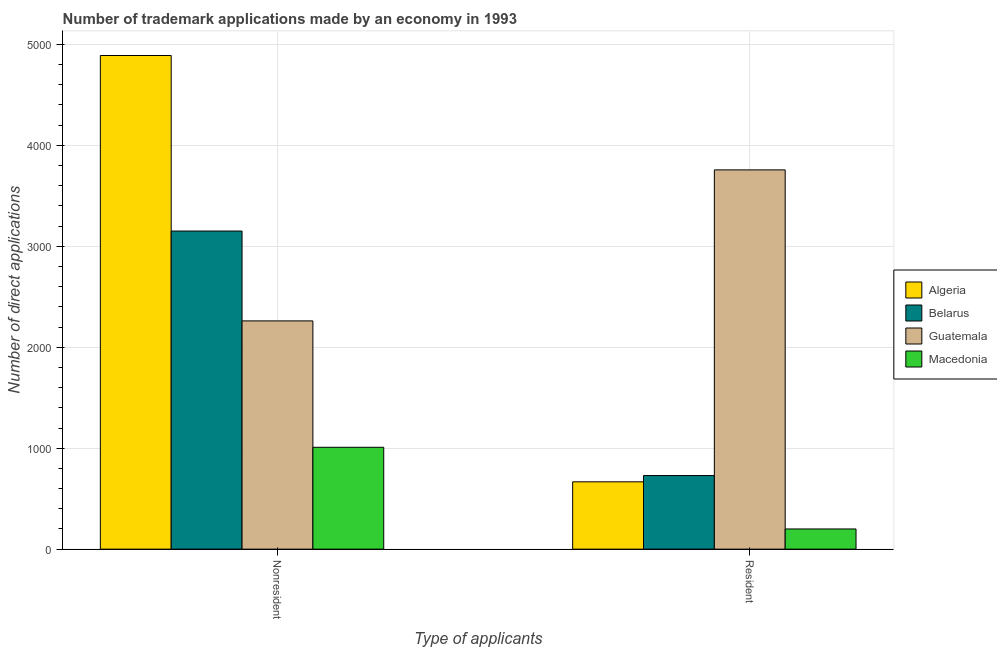How many different coloured bars are there?
Provide a short and direct response. 4. Are the number of bars on each tick of the X-axis equal?
Make the answer very short. Yes. How many bars are there on the 2nd tick from the right?
Give a very brief answer. 4. What is the label of the 1st group of bars from the left?
Make the answer very short. Nonresident. What is the number of trademark applications made by non residents in Algeria?
Offer a very short reply. 4890. Across all countries, what is the maximum number of trademark applications made by residents?
Offer a terse response. 3757. Across all countries, what is the minimum number of trademark applications made by residents?
Provide a succinct answer. 200. In which country was the number of trademark applications made by non residents maximum?
Give a very brief answer. Algeria. In which country was the number of trademark applications made by non residents minimum?
Give a very brief answer. Macedonia. What is the total number of trademark applications made by residents in the graph?
Provide a succinct answer. 5353. What is the difference between the number of trademark applications made by non residents in Guatemala and that in Belarus?
Offer a terse response. -890. What is the difference between the number of trademark applications made by non residents in Algeria and the number of trademark applications made by residents in Macedonia?
Offer a terse response. 4690. What is the average number of trademark applications made by residents per country?
Offer a very short reply. 1338.25. What is the difference between the number of trademark applications made by non residents and number of trademark applications made by residents in Macedonia?
Give a very brief answer. 809. In how many countries, is the number of trademark applications made by non residents greater than 1200 ?
Give a very brief answer. 3. What is the ratio of the number of trademark applications made by residents in Macedonia to that in Algeria?
Give a very brief answer. 0.3. Is the number of trademark applications made by residents in Belarus less than that in Algeria?
Your answer should be very brief. No. In how many countries, is the number of trademark applications made by residents greater than the average number of trademark applications made by residents taken over all countries?
Keep it short and to the point. 1. What does the 4th bar from the left in Nonresident represents?
Your answer should be compact. Macedonia. What does the 4th bar from the right in Resident represents?
Provide a short and direct response. Algeria. What is the difference between two consecutive major ticks on the Y-axis?
Your answer should be very brief. 1000. Does the graph contain any zero values?
Offer a very short reply. No. How are the legend labels stacked?
Your answer should be very brief. Vertical. What is the title of the graph?
Give a very brief answer. Number of trademark applications made by an economy in 1993. Does "Greenland" appear as one of the legend labels in the graph?
Give a very brief answer. No. What is the label or title of the X-axis?
Your answer should be very brief. Type of applicants. What is the label or title of the Y-axis?
Ensure brevity in your answer.  Number of direct applications. What is the Number of direct applications of Algeria in Nonresident?
Offer a terse response. 4890. What is the Number of direct applications in Belarus in Nonresident?
Provide a short and direct response. 3151. What is the Number of direct applications in Guatemala in Nonresident?
Keep it short and to the point. 2261. What is the Number of direct applications in Macedonia in Nonresident?
Make the answer very short. 1009. What is the Number of direct applications of Algeria in Resident?
Give a very brief answer. 667. What is the Number of direct applications in Belarus in Resident?
Offer a terse response. 729. What is the Number of direct applications in Guatemala in Resident?
Offer a very short reply. 3757. What is the Number of direct applications in Macedonia in Resident?
Your answer should be very brief. 200. Across all Type of applicants, what is the maximum Number of direct applications of Algeria?
Your answer should be very brief. 4890. Across all Type of applicants, what is the maximum Number of direct applications of Belarus?
Provide a short and direct response. 3151. Across all Type of applicants, what is the maximum Number of direct applications of Guatemala?
Give a very brief answer. 3757. Across all Type of applicants, what is the maximum Number of direct applications in Macedonia?
Offer a very short reply. 1009. Across all Type of applicants, what is the minimum Number of direct applications in Algeria?
Provide a succinct answer. 667. Across all Type of applicants, what is the minimum Number of direct applications in Belarus?
Offer a terse response. 729. Across all Type of applicants, what is the minimum Number of direct applications in Guatemala?
Offer a very short reply. 2261. What is the total Number of direct applications in Algeria in the graph?
Ensure brevity in your answer.  5557. What is the total Number of direct applications of Belarus in the graph?
Give a very brief answer. 3880. What is the total Number of direct applications in Guatemala in the graph?
Your answer should be compact. 6018. What is the total Number of direct applications of Macedonia in the graph?
Your answer should be very brief. 1209. What is the difference between the Number of direct applications in Algeria in Nonresident and that in Resident?
Keep it short and to the point. 4223. What is the difference between the Number of direct applications in Belarus in Nonresident and that in Resident?
Offer a very short reply. 2422. What is the difference between the Number of direct applications of Guatemala in Nonresident and that in Resident?
Give a very brief answer. -1496. What is the difference between the Number of direct applications of Macedonia in Nonresident and that in Resident?
Ensure brevity in your answer.  809. What is the difference between the Number of direct applications in Algeria in Nonresident and the Number of direct applications in Belarus in Resident?
Make the answer very short. 4161. What is the difference between the Number of direct applications of Algeria in Nonresident and the Number of direct applications of Guatemala in Resident?
Your answer should be compact. 1133. What is the difference between the Number of direct applications in Algeria in Nonresident and the Number of direct applications in Macedonia in Resident?
Your answer should be very brief. 4690. What is the difference between the Number of direct applications of Belarus in Nonresident and the Number of direct applications of Guatemala in Resident?
Your response must be concise. -606. What is the difference between the Number of direct applications in Belarus in Nonresident and the Number of direct applications in Macedonia in Resident?
Your response must be concise. 2951. What is the difference between the Number of direct applications in Guatemala in Nonresident and the Number of direct applications in Macedonia in Resident?
Your response must be concise. 2061. What is the average Number of direct applications of Algeria per Type of applicants?
Provide a short and direct response. 2778.5. What is the average Number of direct applications in Belarus per Type of applicants?
Provide a succinct answer. 1940. What is the average Number of direct applications in Guatemala per Type of applicants?
Your answer should be very brief. 3009. What is the average Number of direct applications in Macedonia per Type of applicants?
Make the answer very short. 604.5. What is the difference between the Number of direct applications in Algeria and Number of direct applications in Belarus in Nonresident?
Keep it short and to the point. 1739. What is the difference between the Number of direct applications of Algeria and Number of direct applications of Guatemala in Nonresident?
Ensure brevity in your answer.  2629. What is the difference between the Number of direct applications of Algeria and Number of direct applications of Macedonia in Nonresident?
Make the answer very short. 3881. What is the difference between the Number of direct applications in Belarus and Number of direct applications in Guatemala in Nonresident?
Provide a succinct answer. 890. What is the difference between the Number of direct applications of Belarus and Number of direct applications of Macedonia in Nonresident?
Keep it short and to the point. 2142. What is the difference between the Number of direct applications of Guatemala and Number of direct applications of Macedonia in Nonresident?
Keep it short and to the point. 1252. What is the difference between the Number of direct applications in Algeria and Number of direct applications in Belarus in Resident?
Your response must be concise. -62. What is the difference between the Number of direct applications in Algeria and Number of direct applications in Guatemala in Resident?
Your answer should be very brief. -3090. What is the difference between the Number of direct applications in Algeria and Number of direct applications in Macedonia in Resident?
Provide a succinct answer. 467. What is the difference between the Number of direct applications in Belarus and Number of direct applications in Guatemala in Resident?
Your answer should be very brief. -3028. What is the difference between the Number of direct applications of Belarus and Number of direct applications of Macedonia in Resident?
Provide a succinct answer. 529. What is the difference between the Number of direct applications of Guatemala and Number of direct applications of Macedonia in Resident?
Provide a short and direct response. 3557. What is the ratio of the Number of direct applications of Algeria in Nonresident to that in Resident?
Ensure brevity in your answer.  7.33. What is the ratio of the Number of direct applications of Belarus in Nonresident to that in Resident?
Provide a short and direct response. 4.32. What is the ratio of the Number of direct applications of Guatemala in Nonresident to that in Resident?
Give a very brief answer. 0.6. What is the ratio of the Number of direct applications of Macedonia in Nonresident to that in Resident?
Give a very brief answer. 5.04. What is the difference between the highest and the second highest Number of direct applications in Algeria?
Make the answer very short. 4223. What is the difference between the highest and the second highest Number of direct applications in Belarus?
Your answer should be very brief. 2422. What is the difference between the highest and the second highest Number of direct applications in Guatemala?
Provide a short and direct response. 1496. What is the difference between the highest and the second highest Number of direct applications in Macedonia?
Provide a succinct answer. 809. What is the difference between the highest and the lowest Number of direct applications in Algeria?
Provide a succinct answer. 4223. What is the difference between the highest and the lowest Number of direct applications in Belarus?
Give a very brief answer. 2422. What is the difference between the highest and the lowest Number of direct applications of Guatemala?
Provide a short and direct response. 1496. What is the difference between the highest and the lowest Number of direct applications of Macedonia?
Provide a succinct answer. 809. 